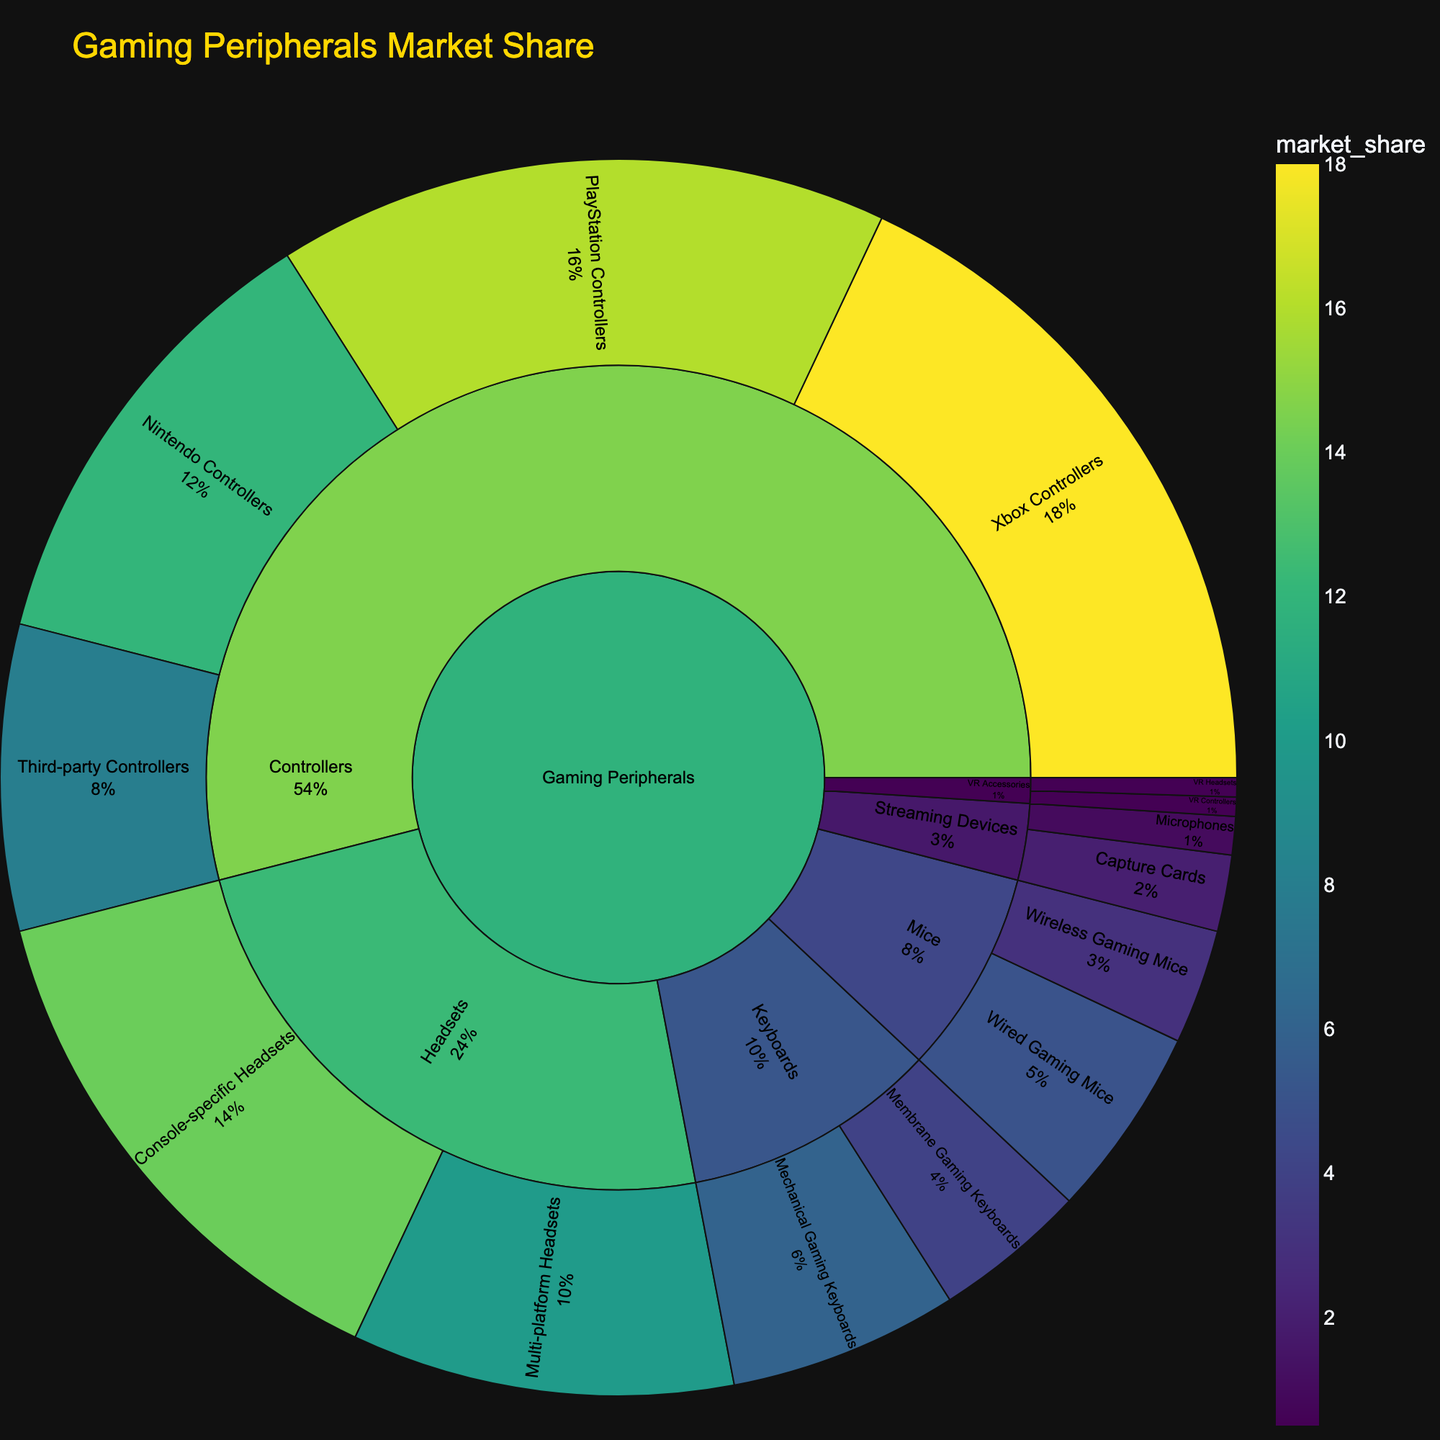what is the title of the figure? The title of the figure is typically displayed prominently at the top and provides an overview of the visualized data. Here, the title of the figure is "Gaming Peripherals Market Share."
Answer: Gaming Peripherals Market Share Which type of controller has the largest market share? By examining the outermost layer of the Controllers section in the sunburst chart, one can observe that Xbox Controllers have the largest market share when compared to other types of controllers.
Answer: Xbox Controllers What is the combined market share of all Headsets? To find the combined market share of all Headsets, sum the shares of Console-specific Headsets and Multi-platform Headsets: 14 + 10 = 24.
Answer: 24 Which subcategory under Gaming Peripherals has the lowest market share? Looking at the subcategories in the sunburst plot, VR Accessories have the lowest market share.
Answer: VR Accessories Compare the market shares of Mechanical and Membrane Gaming Keyboards. Which one is greater? Checking the Keyboard subcategory, Mechanical Gaming Keyboards have a market share of 6, while Membrane Gaming Keyboards have a share of 4. Thus, Mechanical Gaming Keyboards have a greater market share.
Answer: Mechanical Gaming Keyboards List three products with the highest market share. From the outermost ring of the sunburst plot, the three products with the highest market shares are Xbox Controllers (18), PlayStation Controllers (16), and Console-specific Headsets (14).
Answer: Xbox Controllers, PlayStation Controllers, Console-specific Headsets What is the total market share for all types of Mice? Adding the individual market shares for Wired Gaming Mice (5) and Wireless Gaming Mice (3) gives a total market share of 8 for Mice.
Answer: 8 Which category has an item with a market share below 1%? Looking through the categories, the VR Accessories category includes VR Headsets and VR Controllers, each with market shares of 0.5%.
Answer: VR Accessories Which has a larger market share: Nintendo Controllers or all Streaming Devices combined? Nintendo Controllers have a market share of 12. The Streaming Devices total market share is the sum of Capture Cards (2) and Microphones (1), giving a total of 3. Therefore, Nintendo Controllers have a larger market share.
Answer: Nintendo Controllers 